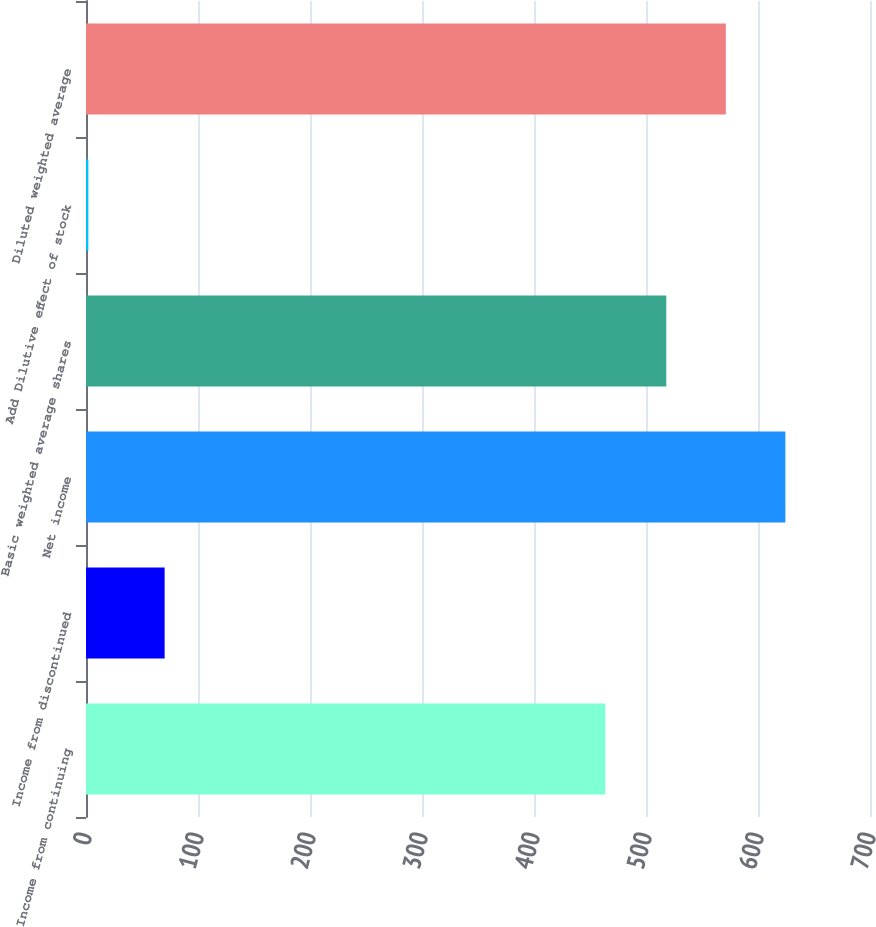Convert chart to OTSL. <chart><loc_0><loc_0><loc_500><loc_500><bar_chart><fcel>Income from continuing<fcel>Income from discontinued<fcel>Net income<fcel>Basic weighted average shares<fcel>Add Dilutive effect of stock<fcel>Diluted weighted average<nl><fcel>463.6<fcel>70.2<fcel>624.44<fcel>518.1<fcel>2.1<fcel>571.27<nl></chart> 